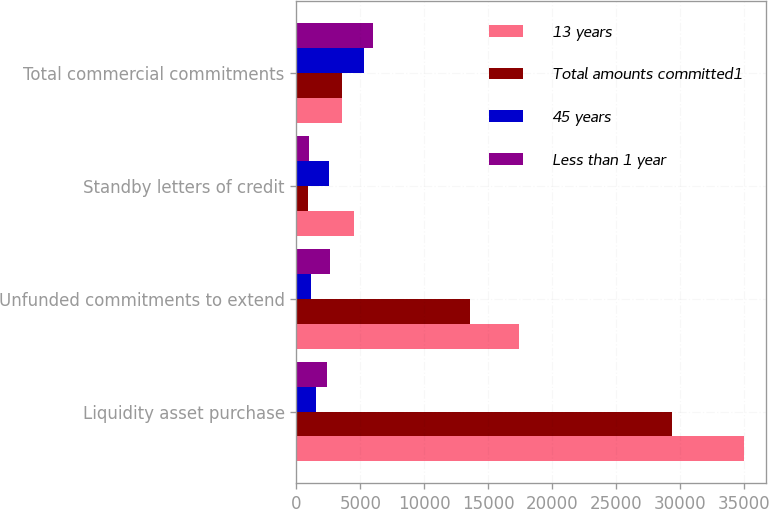Convert chart to OTSL. <chart><loc_0><loc_0><loc_500><loc_500><stacked_bar_chart><ecel><fcel>Liquidity asset purchase<fcel>Unfunded commitments to extend<fcel>Standby letters of credit<fcel>Total commercial commitments<nl><fcel>13 years<fcel>34947<fcel>17404<fcel>4505<fcel>3552<nl><fcel>Total amounts committed1<fcel>29321<fcel>13555<fcel>925<fcel>3552<nl><fcel>45 years<fcel>1569<fcel>1175<fcel>2567<fcel>5311<nl><fcel>Less than 1 year<fcel>2379<fcel>2599<fcel>1002<fcel>5980<nl></chart> 